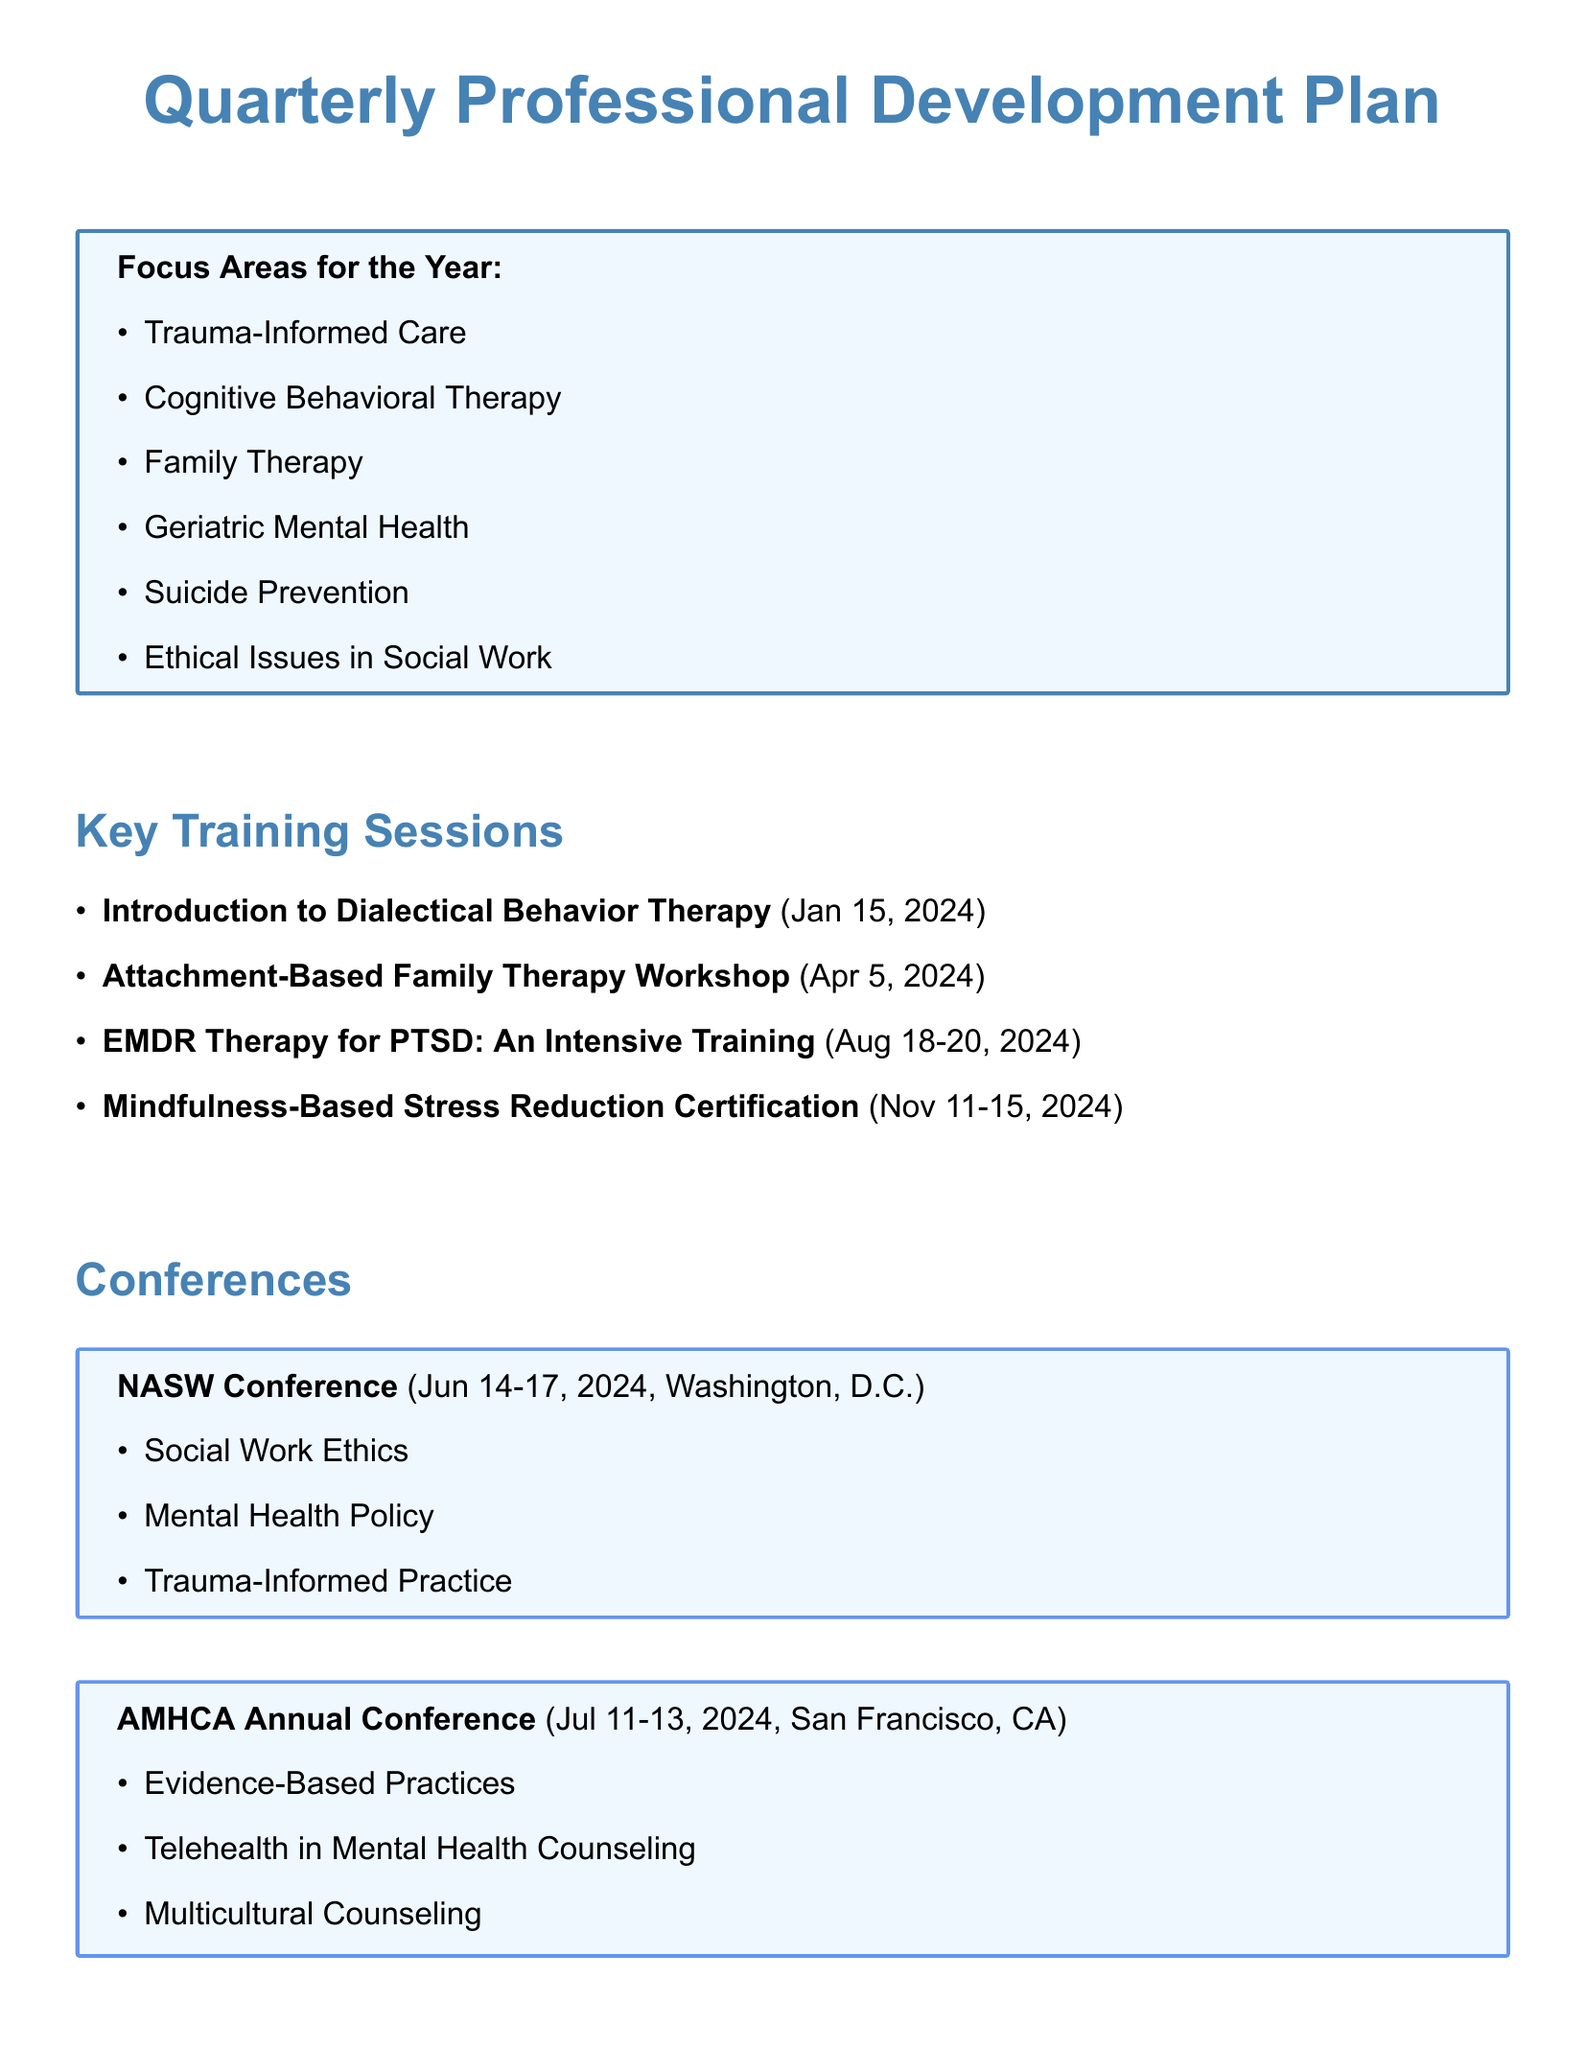What is the focus area for Q1? The focus area for Q1 is mentioned in the document under focus areas for the year, specifically for the first quarter.
Answer: Trauma-Informed Care Who is the presenter for the training session on Crisis Intervention Strategies? The presenter for the training session is listed in the document next to each training session.
Answer: Dr. Albert Roberts When is the NASW Conference scheduled? The dates for the NASW Conference are provided in the conferences section of the document.
Answer: June 14-17, 2024 What is the duration of the Mindfulness-Based Stress Reduction Certification training? The duration is specified in hours next to each training session.
Answer: 40 hours What are the key topics of the AMHCA Annual Conference? The key topics are listed under the conference details in the document.
Answer: Evidence-Based Practices, Telehealth in Mental Health Counseling, Multicultural Counseling How many training sessions are scheduled for Q3? The number of training sessions is determined by counting the entries in the training sessions section for Q3.
Answer: 3 Which training session is focused on family therapy? The document lists training sessions and their titles, one of which is focused on family therapy.
Answer: Attachment-Based Family Therapy Workshop What is the location of the CSWE Annual Program Meeting? The location is specified in the details of the CSWE Annual Program Meeting in the document.
Answer: Atlanta, GA What is the title of the training session on Suicide Risk Assessment? The title of the training session is provided under the training sessions for Q3.
Answer: Advanced Suicide Risk Assessment and Intervention 